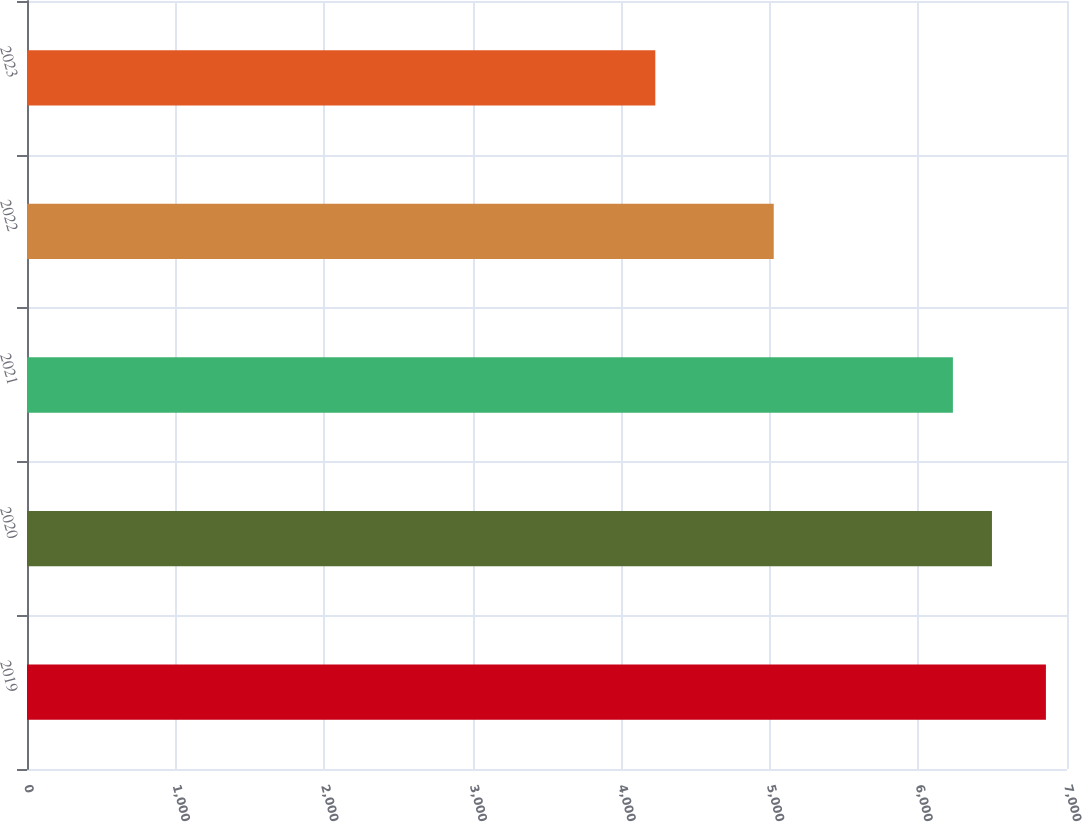<chart> <loc_0><loc_0><loc_500><loc_500><bar_chart><fcel>2019<fcel>2020<fcel>2021<fcel>2022<fcel>2023<nl><fcel>6858<fcel>6494.9<fcel>6232<fcel>5026<fcel>4229<nl></chart> 